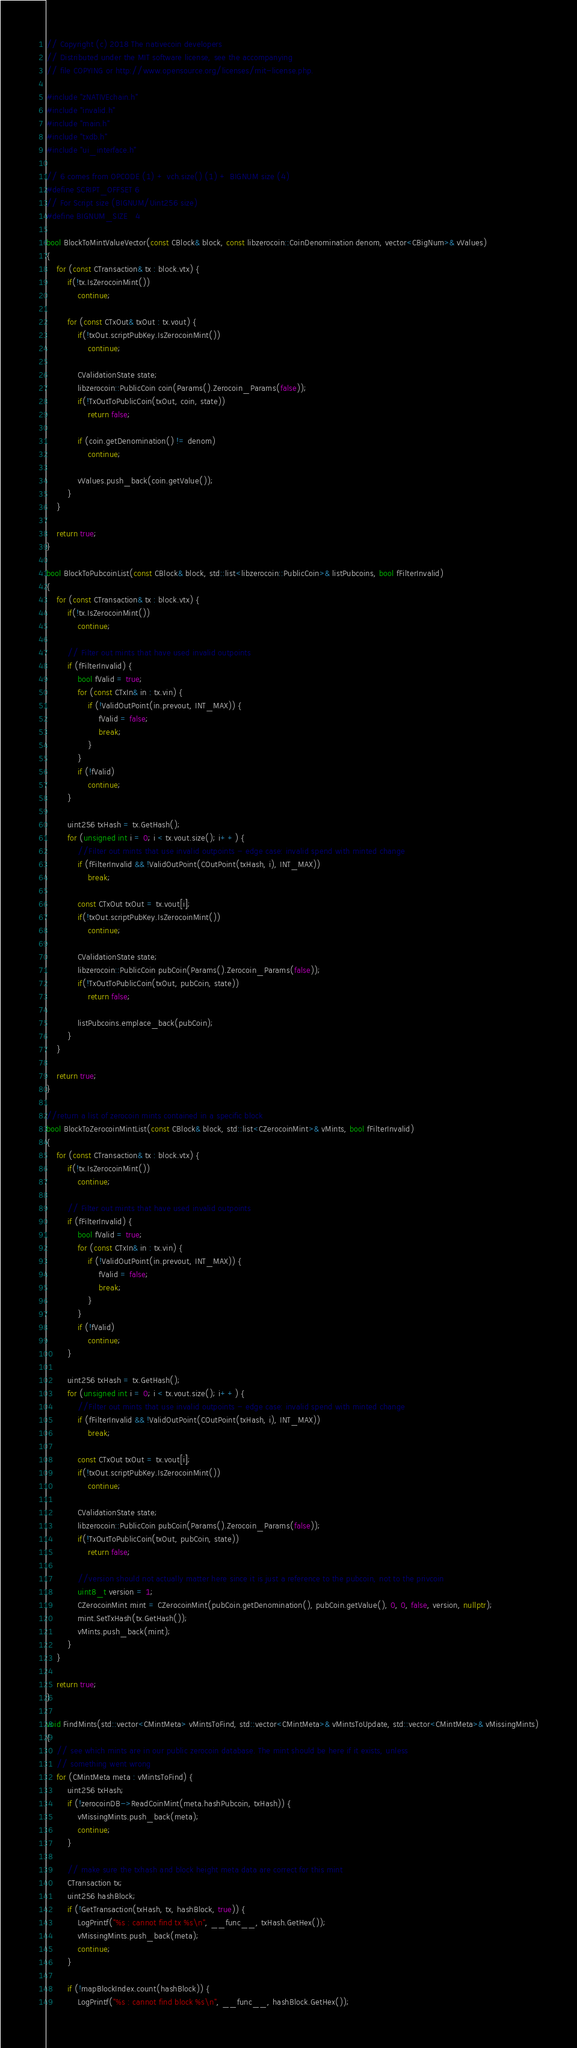<code> <loc_0><loc_0><loc_500><loc_500><_C++_>// Copyright (c) 2018 The nativecoin developers
// Distributed under the MIT software license, see the accompanying
// file COPYING or http://www.opensource.org/licenses/mit-license.php.

#include "zNATIVEchain.h"
#include "invalid.h"
#include "main.h"
#include "txdb.h"
#include "ui_interface.h"

// 6 comes from OPCODE (1) + vch.size() (1) + BIGNUM size (4)
#define SCRIPT_OFFSET 6
// For Script size (BIGNUM/Uint256 size)
#define BIGNUM_SIZE   4

bool BlockToMintValueVector(const CBlock& block, const libzerocoin::CoinDenomination denom, vector<CBigNum>& vValues)
{
    for (const CTransaction& tx : block.vtx) {
        if(!tx.IsZerocoinMint())
            continue;

        for (const CTxOut& txOut : tx.vout) {
            if(!txOut.scriptPubKey.IsZerocoinMint())
                continue;

            CValidationState state;
            libzerocoin::PublicCoin coin(Params().Zerocoin_Params(false));
            if(!TxOutToPublicCoin(txOut, coin, state))
                return false;

            if (coin.getDenomination() != denom)
                continue;

            vValues.push_back(coin.getValue());
        }
    }

    return true;
}

bool BlockToPubcoinList(const CBlock& block, std::list<libzerocoin::PublicCoin>& listPubcoins, bool fFilterInvalid)
{
    for (const CTransaction& tx : block.vtx) {
        if(!tx.IsZerocoinMint())
            continue;

        // Filter out mints that have used invalid outpoints
        if (fFilterInvalid) {
            bool fValid = true;
            for (const CTxIn& in : tx.vin) {
                if (!ValidOutPoint(in.prevout, INT_MAX)) {
                    fValid = false;
                    break;
                }
            }
            if (!fValid)
                continue;
        }

        uint256 txHash = tx.GetHash();
        for (unsigned int i = 0; i < tx.vout.size(); i++) {
            //Filter out mints that use invalid outpoints - edge case: invalid spend with minted change
            if (fFilterInvalid && !ValidOutPoint(COutPoint(txHash, i), INT_MAX))
                break;

            const CTxOut txOut = tx.vout[i];
            if(!txOut.scriptPubKey.IsZerocoinMint())
                continue;

            CValidationState state;
            libzerocoin::PublicCoin pubCoin(Params().Zerocoin_Params(false));
            if(!TxOutToPublicCoin(txOut, pubCoin, state))
                return false;

            listPubcoins.emplace_back(pubCoin);
        }
    }

    return true;
}

//return a list of zerocoin mints contained in a specific block
bool BlockToZerocoinMintList(const CBlock& block, std::list<CZerocoinMint>& vMints, bool fFilterInvalid)
{
    for (const CTransaction& tx : block.vtx) {
        if(!tx.IsZerocoinMint())
            continue;

        // Filter out mints that have used invalid outpoints
        if (fFilterInvalid) {
            bool fValid = true;
            for (const CTxIn& in : tx.vin) {
                if (!ValidOutPoint(in.prevout, INT_MAX)) {
                    fValid = false;
                    break;
                }
            }
            if (!fValid)
                continue;
        }

        uint256 txHash = tx.GetHash();
        for (unsigned int i = 0; i < tx.vout.size(); i++) {
            //Filter out mints that use invalid outpoints - edge case: invalid spend with minted change
            if (fFilterInvalid && !ValidOutPoint(COutPoint(txHash, i), INT_MAX))
                break;

            const CTxOut txOut = tx.vout[i];
            if(!txOut.scriptPubKey.IsZerocoinMint())
                continue;

            CValidationState state;
            libzerocoin::PublicCoin pubCoin(Params().Zerocoin_Params(false));
            if(!TxOutToPublicCoin(txOut, pubCoin, state))
                return false;

            //version should not actually matter here since it is just a reference to the pubcoin, not to the privcoin
            uint8_t version = 1;
            CZerocoinMint mint = CZerocoinMint(pubCoin.getDenomination(), pubCoin.getValue(), 0, 0, false, version, nullptr);
            mint.SetTxHash(tx.GetHash());
            vMints.push_back(mint);
        }
    }

    return true;
}

void FindMints(std::vector<CMintMeta> vMintsToFind, std::vector<CMintMeta>& vMintsToUpdate, std::vector<CMintMeta>& vMissingMints)
{
    // see which mints are in our public zerocoin database. The mint should be here if it exists, unless
    // something went wrong
    for (CMintMeta meta : vMintsToFind) {
        uint256 txHash;
        if (!zerocoinDB->ReadCoinMint(meta.hashPubcoin, txHash)) {
            vMissingMints.push_back(meta);
            continue;
        }

        // make sure the txhash and block height meta data are correct for this mint
        CTransaction tx;
        uint256 hashBlock;
        if (!GetTransaction(txHash, tx, hashBlock, true)) {
            LogPrintf("%s : cannot find tx %s\n", __func__, txHash.GetHex());
            vMissingMints.push_back(meta);
            continue;
        }

        if (!mapBlockIndex.count(hashBlock)) {
            LogPrintf("%s : cannot find block %s\n", __func__, hashBlock.GetHex());</code> 